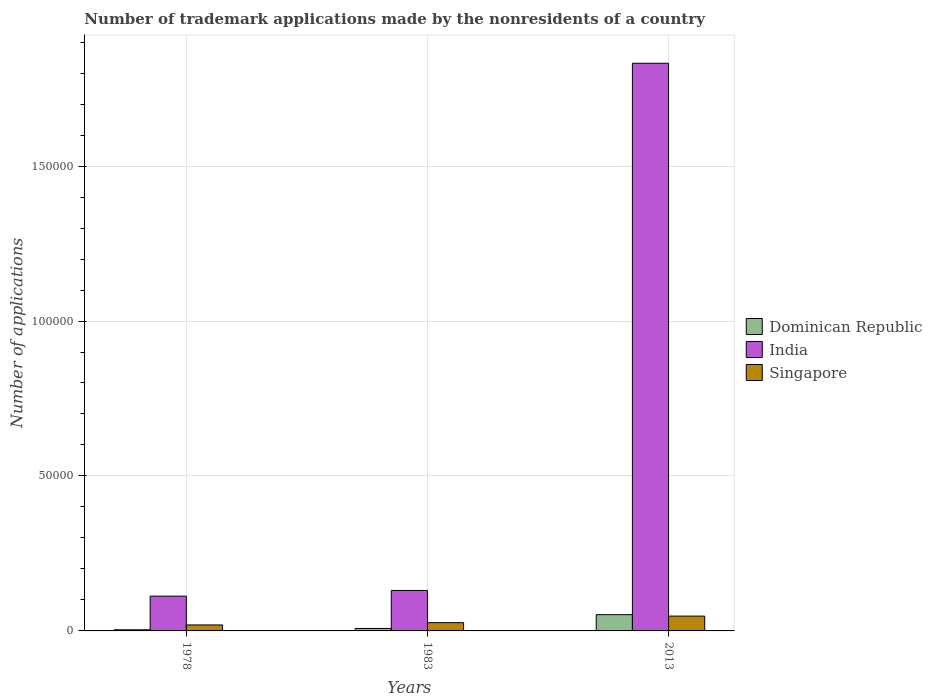How many different coloured bars are there?
Your response must be concise. 3. How many bars are there on the 2nd tick from the left?
Ensure brevity in your answer.  3. In how many cases, is the number of bars for a given year not equal to the number of legend labels?
Ensure brevity in your answer.  0. What is the number of trademark applications made by the nonresidents in Singapore in 1978?
Give a very brief answer. 1932. Across all years, what is the maximum number of trademark applications made by the nonresidents in Singapore?
Provide a succinct answer. 4787. Across all years, what is the minimum number of trademark applications made by the nonresidents in Singapore?
Your answer should be very brief. 1932. In which year was the number of trademark applications made by the nonresidents in India maximum?
Your answer should be very brief. 2013. In which year was the number of trademark applications made by the nonresidents in India minimum?
Ensure brevity in your answer.  1978. What is the total number of trademark applications made by the nonresidents in Singapore in the graph?
Offer a very short reply. 9383. What is the difference between the number of trademark applications made by the nonresidents in Dominican Republic in 1978 and that in 1983?
Provide a short and direct response. -427. What is the difference between the number of trademark applications made by the nonresidents in India in 1983 and the number of trademark applications made by the nonresidents in Singapore in 2013?
Your answer should be very brief. 8262. What is the average number of trademark applications made by the nonresidents in Singapore per year?
Keep it short and to the point. 3127.67. In the year 1983, what is the difference between the number of trademark applications made by the nonresidents in Singapore and number of trademark applications made by the nonresidents in India?
Provide a short and direct response. -1.04e+04. In how many years, is the number of trademark applications made by the nonresidents in Dominican Republic greater than 150000?
Make the answer very short. 0. What is the ratio of the number of trademark applications made by the nonresidents in India in 1978 to that in 1983?
Offer a terse response. 0.86. Is the number of trademark applications made by the nonresidents in India in 1978 less than that in 1983?
Offer a terse response. Yes. What is the difference between the highest and the second highest number of trademark applications made by the nonresidents in India?
Give a very brief answer. 1.70e+05. What is the difference between the highest and the lowest number of trademark applications made by the nonresidents in Singapore?
Provide a succinct answer. 2855. Is the sum of the number of trademark applications made by the nonresidents in India in 1978 and 1983 greater than the maximum number of trademark applications made by the nonresidents in Singapore across all years?
Give a very brief answer. Yes. What does the 2nd bar from the left in 1983 represents?
Your response must be concise. India. What does the 3rd bar from the right in 2013 represents?
Offer a very short reply. Dominican Republic. Is it the case that in every year, the sum of the number of trademark applications made by the nonresidents in Singapore and number of trademark applications made by the nonresidents in India is greater than the number of trademark applications made by the nonresidents in Dominican Republic?
Make the answer very short. Yes. How many years are there in the graph?
Your response must be concise. 3. What is the difference between two consecutive major ticks on the Y-axis?
Provide a short and direct response. 5.00e+04. Are the values on the major ticks of Y-axis written in scientific E-notation?
Give a very brief answer. No. Does the graph contain grids?
Your response must be concise. Yes. Where does the legend appear in the graph?
Your answer should be very brief. Center right. How are the legend labels stacked?
Make the answer very short. Vertical. What is the title of the graph?
Offer a terse response. Number of trademark applications made by the nonresidents of a country. Does "Vanuatu" appear as one of the legend labels in the graph?
Offer a very short reply. No. What is the label or title of the X-axis?
Offer a terse response. Years. What is the label or title of the Y-axis?
Keep it short and to the point. Number of applications. What is the Number of applications in Dominican Republic in 1978?
Give a very brief answer. 363. What is the Number of applications of India in 1978?
Your answer should be very brief. 1.12e+04. What is the Number of applications in Singapore in 1978?
Your answer should be compact. 1932. What is the Number of applications in Dominican Republic in 1983?
Make the answer very short. 790. What is the Number of applications in India in 1983?
Offer a terse response. 1.30e+04. What is the Number of applications in Singapore in 1983?
Your answer should be compact. 2664. What is the Number of applications in Dominican Republic in 2013?
Keep it short and to the point. 5248. What is the Number of applications in India in 2013?
Offer a very short reply. 1.83e+05. What is the Number of applications of Singapore in 2013?
Your answer should be compact. 4787. Across all years, what is the maximum Number of applications in Dominican Republic?
Offer a terse response. 5248. Across all years, what is the maximum Number of applications in India?
Give a very brief answer. 1.83e+05. Across all years, what is the maximum Number of applications of Singapore?
Ensure brevity in your answer.  4787. Across all years, what is the minimum Number of applications in Dominican Republic?
Offer a terse response. 363. Across all years, what is the minimum Number of applications in India?
Provide a succinct answer. 1.12e+04. Across all years, what is the minimum Number of applications in Singapore?
Offer a very short reply. 1932. What is the total Number of applications in Dominican Republic in the graph?
Provide a succinct answer. 6401. What is the total Number of applications in India in the graph?
Offer a very short reply. 2.07e+05. What is the total Number of applications of Singapore in the graph?
Provide a succinct answer. 9383. What is the difference between the Number of applications in Dominican Republic in 1978 and that in 1983?
Offer a terse response. -427. What is the difference between the Number of applications of India in 1978 and that in 1983?
Offer a terse response. -1823. What is the difference between the Number of applications of Singapore in 1978 and that in 1983?
Make the answer very short. -732. What is the difference between the Number of applications of Dominican Republic in 1978 and that in 2013?
Give a very brief answer. -4885. What is the difference between the Number of applications in India in 1978 and that in 2013?
Make the answer very short. -1.72e+05. What is the difference between the Number of applications in Singapore in 1978 and that in 2013?
Provide a succinct answer. -2855. What is the difference between the Number of applications in Dominican Republic in 1983 and that in 2013?
Your response must be concise. -4458. What is the difference between the Number of applications of India in 1983 and that in 2013?
Your answer should be very brief. -1.70e+05. What is the difference between the Number of applications of Singapore in 1983 and that in 2013?
Provide a short and direct response. -2123. What is the difference between the Number of applications in Dominican Republic in 1978 and the Number of applications in India in 1983?
Keep it short and to the point. -1.27e+04. What is the difference between the Number of applications of Dominican Republic in 1978 and the Number of applications of Singapore in 1983?
Give a very brief answer. -2301. What is the difference between the Number of applications in India in 1978 and the Number of applications in Singapore in 1983?
Offer a very short reply. 8562. What is the difference between the Number of applications in Dominican Republic in 1978 and the Number of applications in India in 2013?
Keep it short and to the point. -1.83e+05. What is the difference between the Number of applications of Dominican Republic in 1978 and the Number of applications of Singapore in 2013?
Give a very brief answer. -4424. What is the difference between the Number of applications of India in 1978 and the Number of applications of Singapore in 2013?
Your response must be concise. 6439. What is the difference between the Number of applications of Dominican Republic in 1983 and the Number of applications of India in 2013?
Provide a short and direct response. -1.82e+05. What is the difference between the Number of applications in Dominican Republic in 1983 and the Number of applications in Singapore in 2013?
Your answer should be very brief. -3997. What is the difference between the Number of applications in India in 1983 and the Number of applications in Singapore in 2013?
Your answer should be compact. 8262. What is the average Number of applications of Dominican Republic per year?
Your answer should be very brief. 2133.67. What is the average Number of applications of India per year?
Make the answer very short. 6.91e+04. What is the average Number of applications in Singapore per year?
Provide a short and direct response. 3127.67. In the year 1978, what is the difference between the Number of applications of Dominican Republic and Number of applications of India?
Provide a succinct answer. -1.09e+04. In the year 1978, what is the difference between the Number of applications in Dominican Republic and Number of applications in Singapore?
Provide a succinct answer. -1569. In the year 1978, what is the difference between the Number of applications in India and Number of applications in Singapore?
Keep it short and to the point. 9294. In the year 1983, what is the difference between the Number of applications of Dominican Republic and Number of applications of India?
Your answer should be very brief. -1.23e+04. In the year 1983, what is the difference between the Number of applications in Dominican Republic and Number of applications in Singapore?
Provide a succinct answer. -1874. In the year 1983, what is the difference between the Number of applications of India and Number of applications of Singapore?
Your answer should be very brief. 1.04e+04. In the year 2013, what is the difference between the Number of applications in Dominican Republic and Number of applications in India?
Make the answer very short. -1.78e+05. In the year 2013, what is the difference between the Number of applications in Dominican Republic and Number of applications in Singapore?
Give a very brief answer. 461. In the year 2013, what is the difference between the Number of applications in India and Number of applications in Singapore?
Your answer should be very brief. 1.78e+05. What is the ratio of the Number of applications of Dominican Republic in 1978 to that in 1983?
Your answer should be very brief. 0.46. What is the ratio of the Number of applications in India in 1978 to that in 1983?
Provide a short and direct response. 0.86. What is the ratio of the Number of applications in Singapore in 1978 to that in 1983?
Provide a succinct answer. 0.73. What is the ratio of the Number of applications in Dominican Republic in 1978 to that in 2013?
Ensure brevity in your answer.  0.07. What is the ratio of the Number of applications in India in 1978 to that in 2013?
Keep it short and to the point. 0.06. What is the ratio of the Number of applications of Singapore in 1978 to that in 2013?
Keep it short and to the point. 0.4. What is the ratio of the Number of applications of Dominican Republic in 1983 to that in 2013?
Your response must be concise. 0.15. What is the ratio of the Number of applications in India in 1983 to that in 2013?
Your answer should be very brief. 0.07. What is the ratio of the Number of applications of Singapore in 1983 to that in 2013?
Your answer should be compact. 0.56. What is the difference between the highest and the second highest Number of applications of Dominican Republic?
Your answer should be very brief. 4458. What is the difference between the highest and the second highest Number of applications in India?
Your answer should be compact. 1.70e+05. What is the difference between the highest and the second highest Number of applications of Singapore?
Offer a very short reply. 2123. What is the difference between the highest and the lowest Number of applications of Dominican Republic?
Your answer should be compact. 4885. What is the difference between the highest and the lowest Number of applications of India?
Keep it short and to the point. 1.72e+05. What is the difference between the highest and the lowest Number of applications in Singapore?
Provide a short and direct response. 2855. 